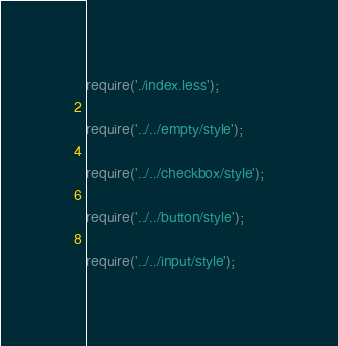<code> <loc_0><loc_0><loc_500><loc_500><_JavaScript_>require('./index.less');

require('../../empty/style');

require('../../checkbox/style');

require('../../button/style');

require('../../input/style');</code> 